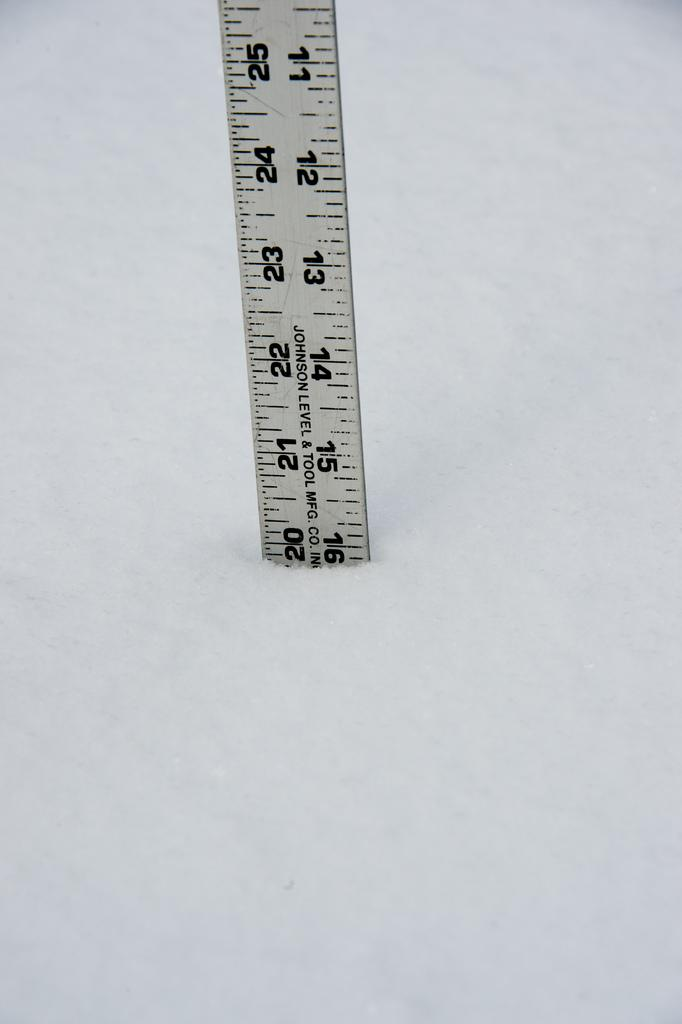<image>
Describe the image concisely. A ruler made by Johnson Level & Tool Mfg. company. 